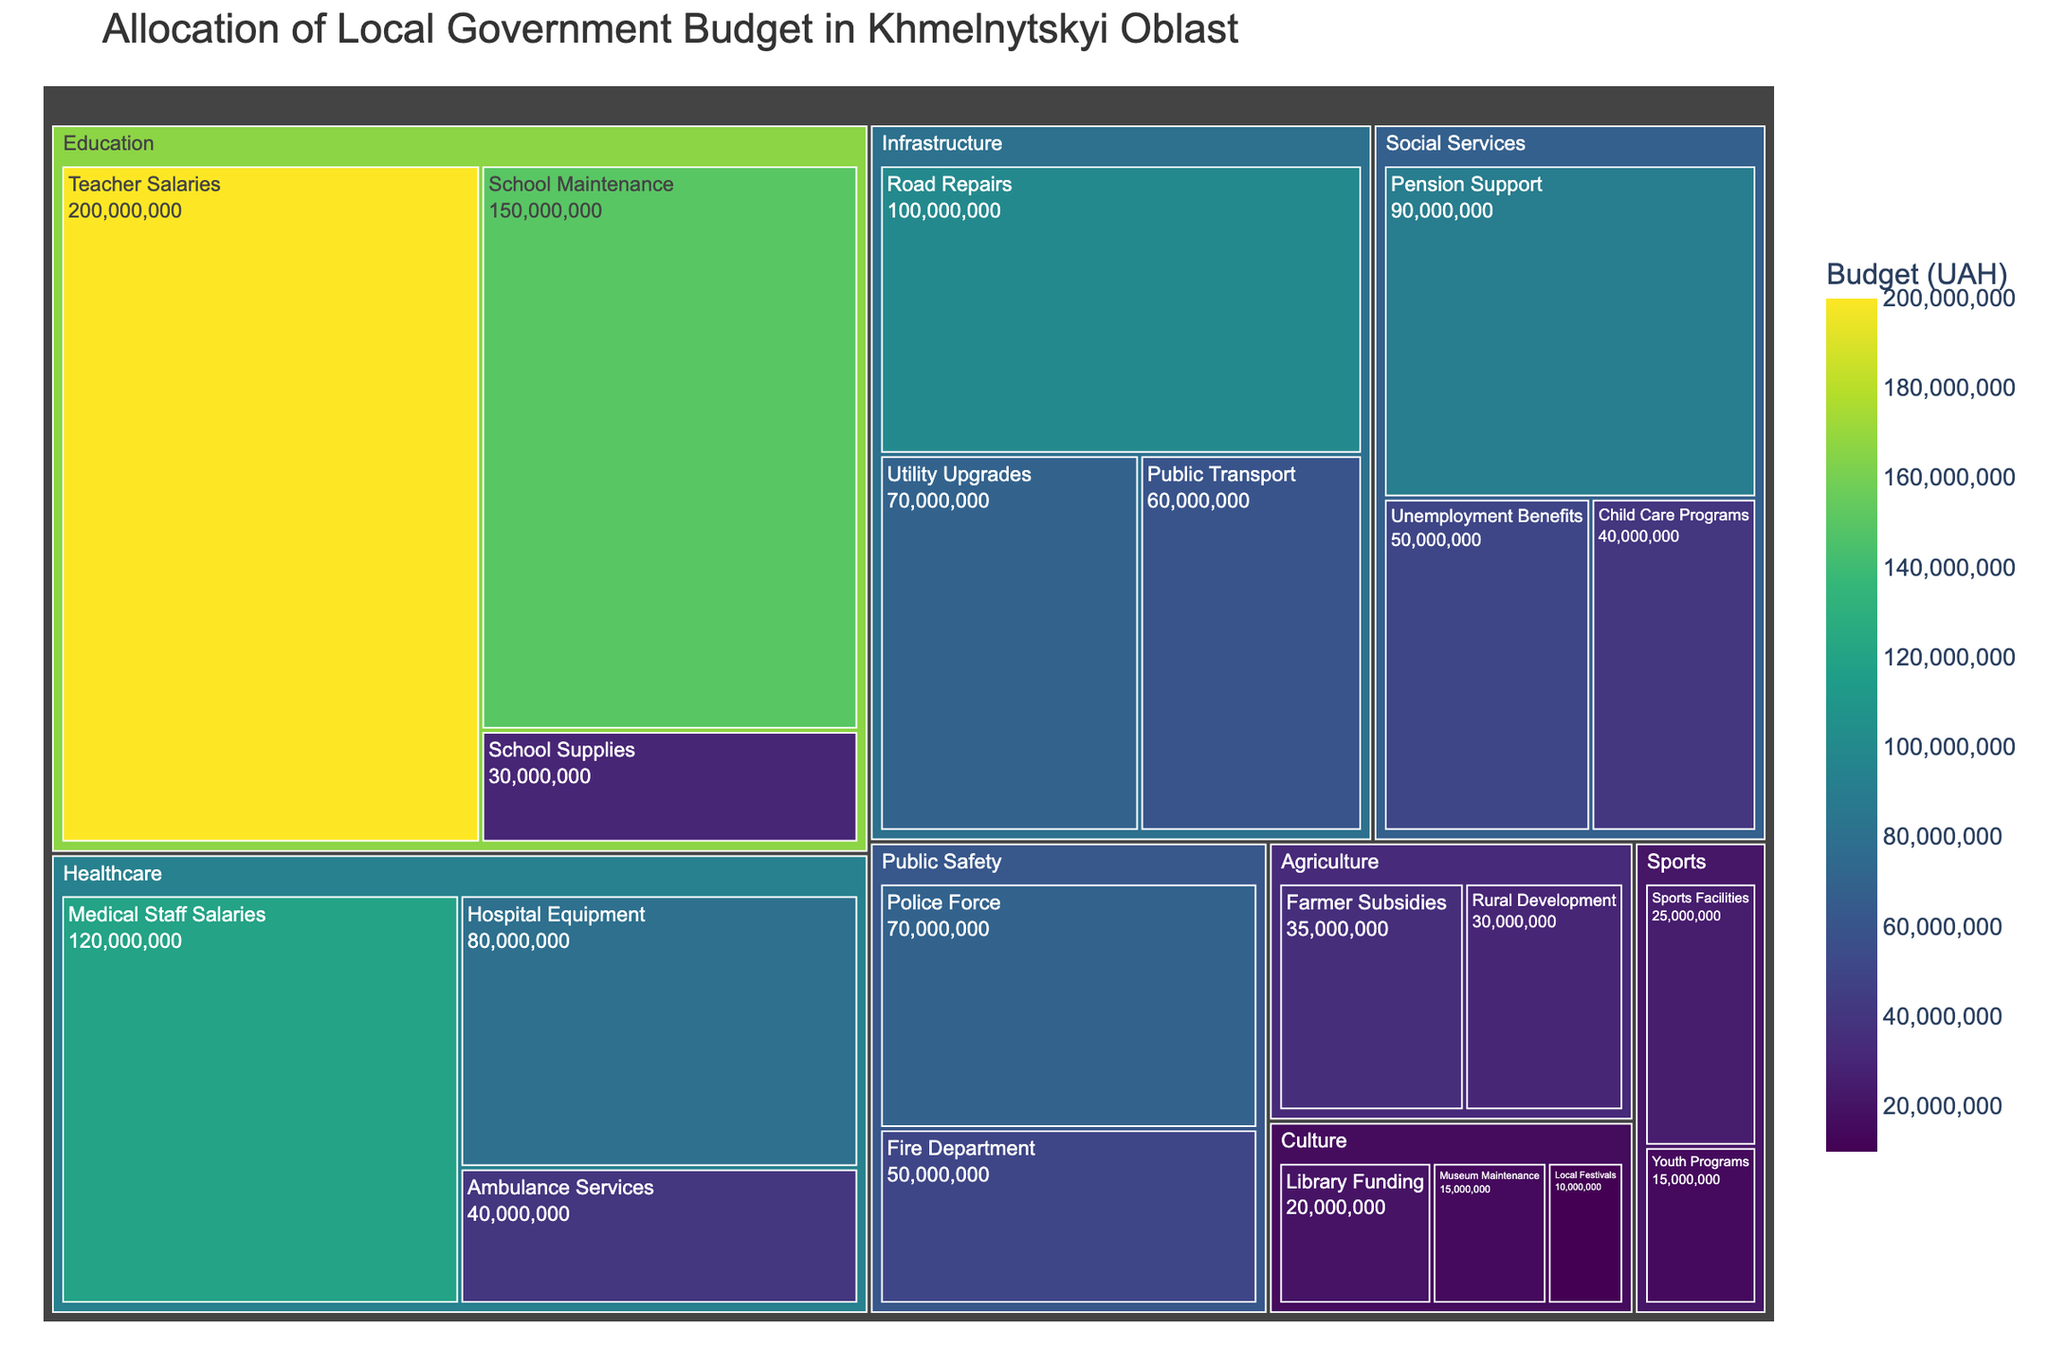What is the total budget allocated to the Education department? Combine the budget amounts for School Maintenance, Teacher Salaries, and School Supplies. That is 150,000,000 + 200,000,000 + 30,000,000 = 380,000,000 UAH.
Answer: 380,000,000 UAH Which department has the largest single program allocation? Look for the largest box within the treemap, which represents Teacher Salaries in the Education department at 200,000,000 UAH.
Answer: Education (Teacher Salaries) How does the budget for Hospital Equipment compare to that for Medical Staff Salaries in Healthcare? Compare the amounts: Hospital Equipment is 80,000,000 UAH, while Medical Staff Salaries is 120,000,000 UAH. Medical Staff Salaries has a higher budget allocation.
Answer: Medical Staff Salaries is higher What is the combined budget for all programs under Social Services? Sum up the amounts for Pension Support, Unemployment Benefits, and Child Care Programs: 90,000,000 + 50,000,000 + 40,000,000 = 180,000,000 UAH.
Answer: 180,000,000 UAH Which program in the Infrastructure department received the least funding? Observe and identify the smallest colored box within the Infrastructure section; it's Public Transport at 60,000,000 UAH.
Answer: Public Transport Between Sports and Culture, which department has a higher total allocation, and by how much? Add up respective program allocations: Sports (25,000,000 + 15,000,000 = 40,000,000 UAH) and Culture (20,000,000 + 15,000,000 + 10,000,000 = 45,000,000 UAH). Culture has more by 5,000,000 UAH.
Answer: Culture, 5,000,000 UAH Which department has the closest total budget allocation to 100,000,000 UAH? Calculate total allocations: Culture 45,000,000 UAH, Sports 40,000,000 UAH, Agriculture 65,000,000 UAH, Public Safety 120,000,000 UAH. Agriculture at 65,000,000 UAH is closest to 100,000,000 UAH.
Answer: Agriculture What is the relative size of the budget for Utility Upgrades compared to Road Repairs? Compare amounts: Utility Upgrades is 70,000,000 UAH, Road Repairs is 100,000,000 UAH. Road Repairs has a larger budget.
Answer: Road Repairs is larger If the total budget were to be evenly distributed among all departments, how much would each department receive? Calculate total budget: 1,030,000,000 UAH. There are 8 departments, so each would receive 1,030,000,000 / 8 = 128,750,000 UAH.
Answer: 128,750,000 UAH 